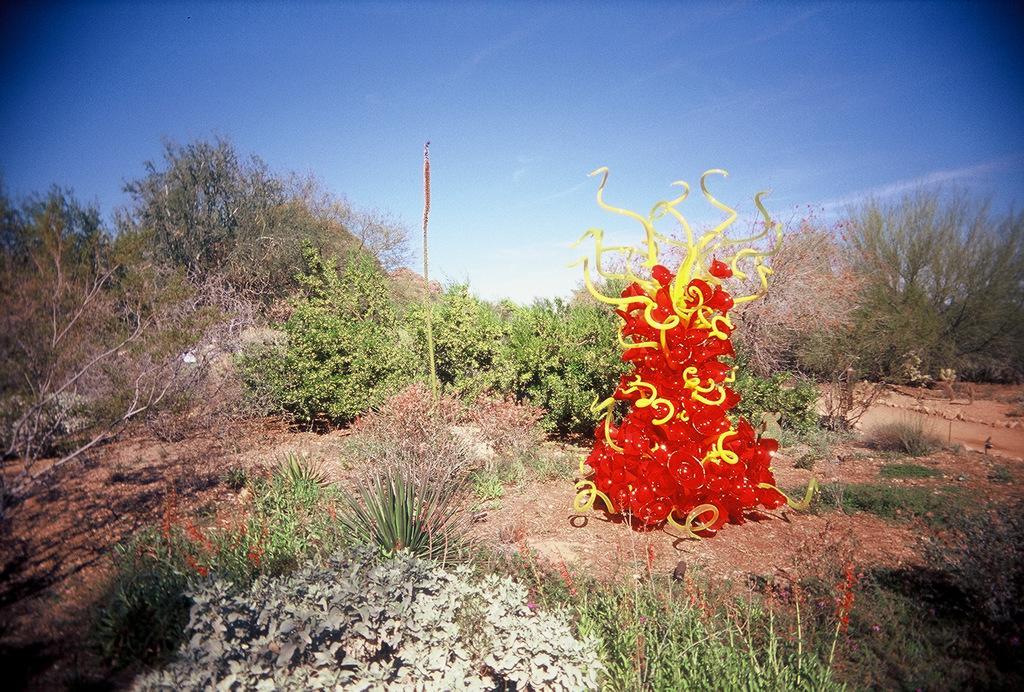Describe this image in one or two sentences. In the background we can see the sky, trees. In this picture we can see the plants and a colorful tree which is yellow and red in color. 